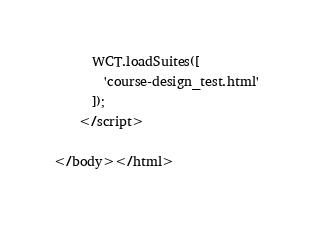<code> <loc_0><loc_0><loc_500><loc_500><_HTML_>      WCT.loadSuites([
        'course-design_test.html'
      ]);
    </script>

</body></html>
</code> 